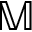<formula> <loc_0><loc_0><loc_500><loc_500>\mathbb { M }</formula> 